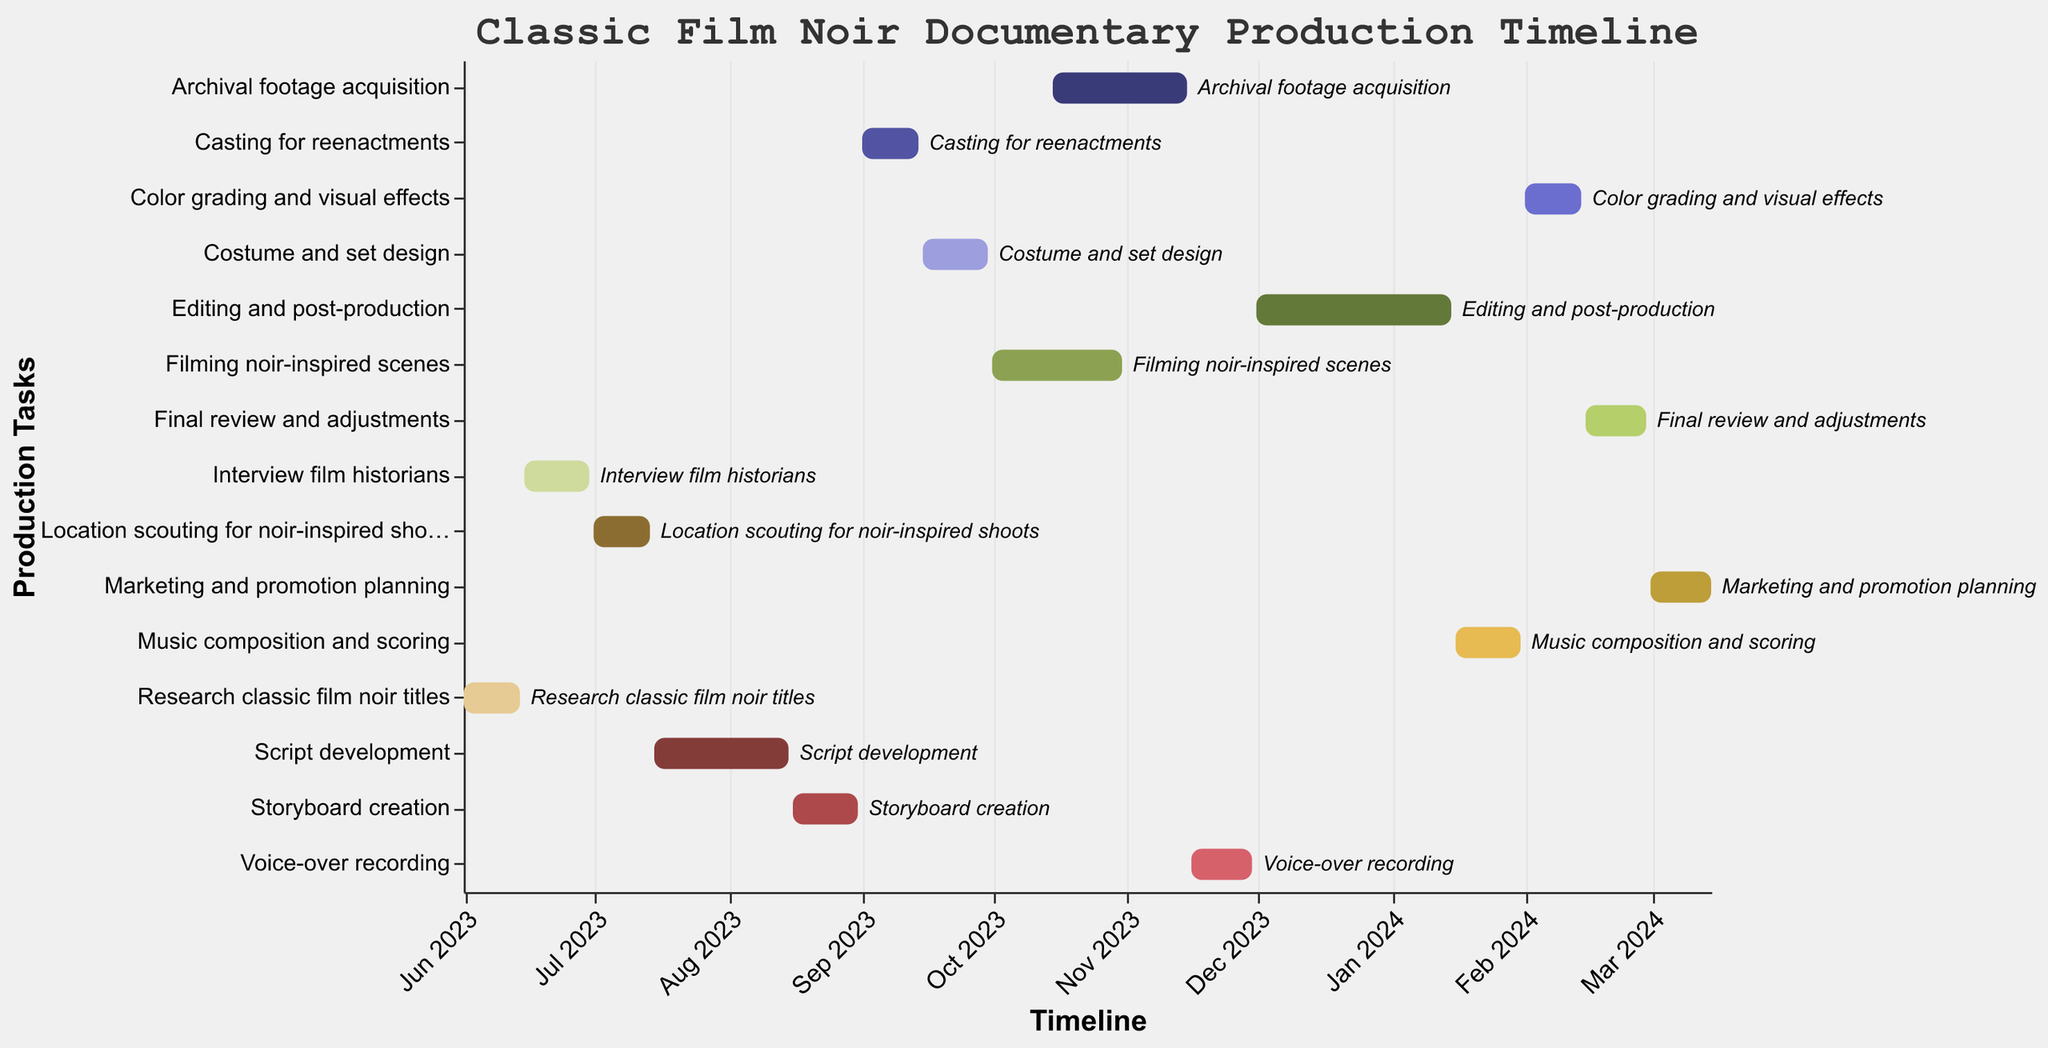How many tasks are displayed in the Gantt Chart? Count the number of unique tasks listed on the y-axis of the Gantt Chart.
Answer: 15 Which task starts immediately after "Research classic film noir titles"? Look at the timeline on the x-axis and note the ending date of "Research classic film noir titles". Then identify the task that starts right after the ending date.
Answer: Interview film historians What is the total duration of the "Filming noir-inspired scenes" task? Calculate the difference between the start and end dates of "Filming noir-inspired scenes".
Answer: 31 days Which tasks overlap in the timeline? Inspect the bars on the Gantt Chart to see which tasks have overlapping date ranges.
Answer: Filming noir-inspired scenes and Archival footage acquisition Does "Voice-over recording" take place before or after the "Editing and post-production"? Compare the start dates of "Voice-over recording" and "Editing and post-production" to determine the order.
Answer: Before Which task has the longest duration in the Gantt Chart? Compare the lengths of all the tasks by looking at the duration between their start and end dates.
Answer: Editing and post-production How many tasks are scheduled to be completed by the end of 2023? Identify the tasks that have end dates falling before or on December 31, 2023.
Answer: 9 What is the duration of time between the start of "Script development" and the end of "Storyboard creation"? Calculate the difference between the start date of "Script development" and the end date of "Storyboard creation".
Answer: 2.5 months Which tasks are scheduled in the month of June 2023? Check the Gantt Chart for tasks that have start or end dates within June 2023.
Answer: Research classic film noir titles and Interview film historians How long is the gap between “Storyboard creation” and “Casting for reenactments”? Determine the end date of “Storyboard creation” and the start date of “Casting for reenactments”, then calculate the gap in days.
Answer: 1 day 